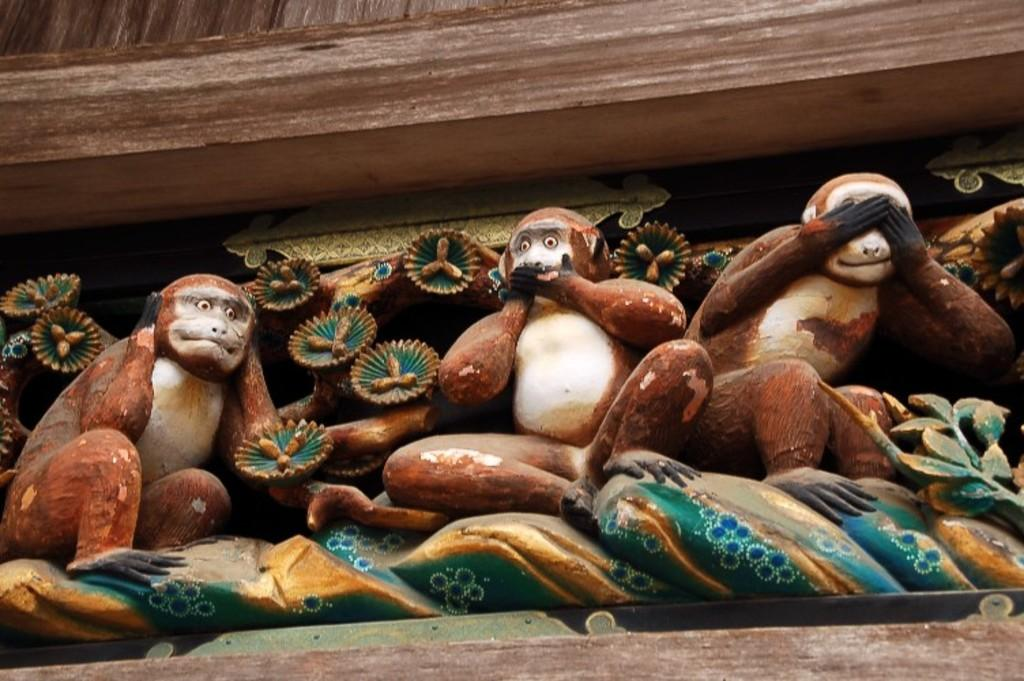How many monkeys are in the image? There are three monkeys in the image. What is the first monkey doing with its hands? The first monkey is closing its ears with its hands. What is the second monkey doing with its hands? The second monkey is closing its mouth with its hands. What is the third monkey doing with its hands? The third monkey is closing its eyes with its hands. What level of difficulty does the monkey achieve in the image? There is no indication of a level of difficulty in the image, as it simply depicts three monkeys performing actions with their hands. 